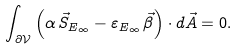<formula> <loc_0><loc_0><loc_500><loc_500>\int _ { \partial \mathcal { V } } \left ( \alpha \, \vec { S } _ { E _ { \infty } } - \varepsilon _ { E _ { \infty } } \, \vec { \beta } \right ) \cdot d \vec { A } = 0 .</formula> 